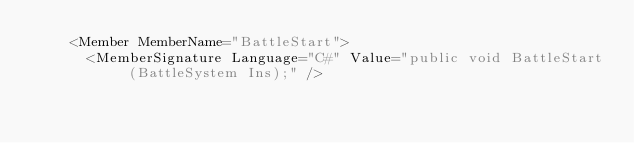Convert code to text. <code><loc_0><loc_0><loc_500><loc_500><_XML_>    <Member MemberName="BattleStart">
      <MemberSignature Language="C#" Value="public void BattleStart (BattleSystem Ins);" /></code> 